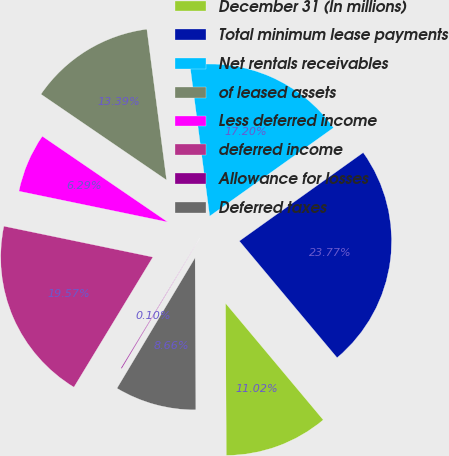Convert chart. <chart><loc_0><loc_0><loc_500><loc_500><pie_chart><fcel>December 31 (In millions)<fcel>Total minimum lease payments<fcel>Net rentals receivables<fcel>of leased assets<fcel>Less deferred income<fcel>deferred income<fcel>Allowance for losses<fcel>Deferred taxes<nl><fcel>11.02%<fcel>23.77%<fcel>17.2%<fcel>13.39%<fcel>6.29%<fcel>19.57%<fcel>0.1%<fcel>8.66%<nl></chart> 